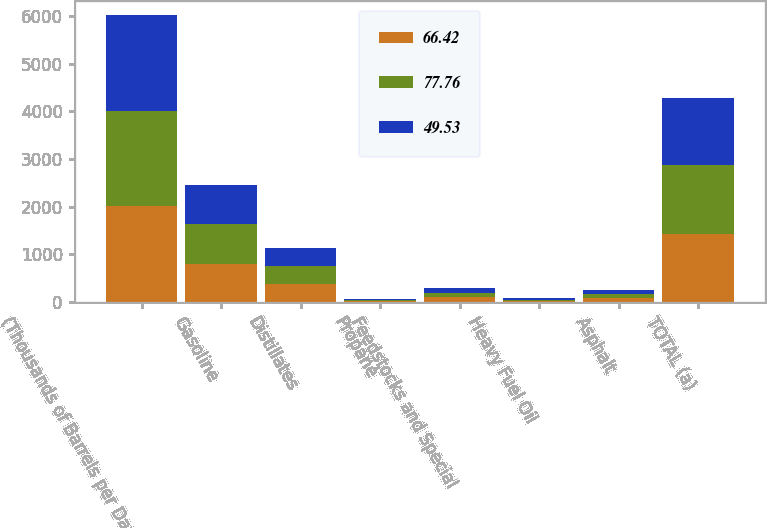Convert chart. <chart><loc_0><loc_0><loc_500><loc_500><stacked_bar_chart><ecel><fcel>(Thousands of Barrels per Day)<fcel>Gasoline<fcel>Distillates<fcel>Propane<fcel>Feedstocks and Special<fcel>Heavy Fuel Oil<fcel>Asphalt<fcel>TOTAL (a)<nl><fcel>66.42<fcel>2006<fcel>804<fcel>375<fcel>23<fcel>106<fcel>26<fcel>91<fcel>1425<nl><fcel>77.76<fcel>2005<fcel>836<fcel>385<fcel>22<fcel>96<fcel>29<fcel>87<fcel>1455<nl><fcel>49.53<fcel>2004<fcel>807<fcel>373<fcel>22<fcel>92<fcel>27<fcel>79<fcel>1400<nl></chart> 